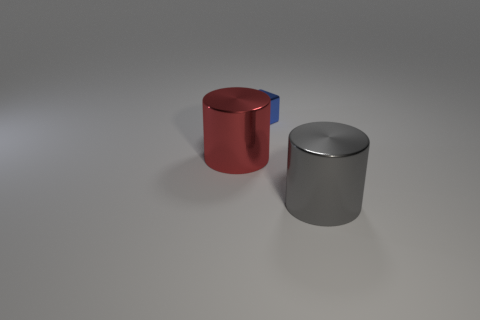There is a cylinder that is the same size as the red metal thing; what material is it?
Your answer should be compact. Metal. Does the metallic object that is in front of the large red shiny thing have the same size as the object on the left side of the blue metallic thing?
Provide a succinct answer. Yes. Is there a tiny red cylinder that has the same material as the cube?
Offer a very short reply. No. How many objects are things in front of the big red cylinder or tiny cubes?
Provide a succinct answer. 2. Does the thing that is to the left of the tiny block have the same material as the big gray object?
Give a very brief answer. Yes. Do the gray metallic thing and the big red shiny thing have the same shape?
Keep it short and to the point. Yes. There is a metallic thing that is in front of the red metal thing; what number of metallic things are in front of it?
Your answer should be very brief. 0. There is a big red object that is the same shape as the big gray object; what is its material?
Offer a terse response. Metal. There is a large shiny thing on the left side of the big gray object; is it the same color as the tiny block?
Provide a short and direct response. No. Is the blue object made of the same material as the gray thing that is on the right side of the big red shiny cylinder?
Provide a succinct answer. Yes. 